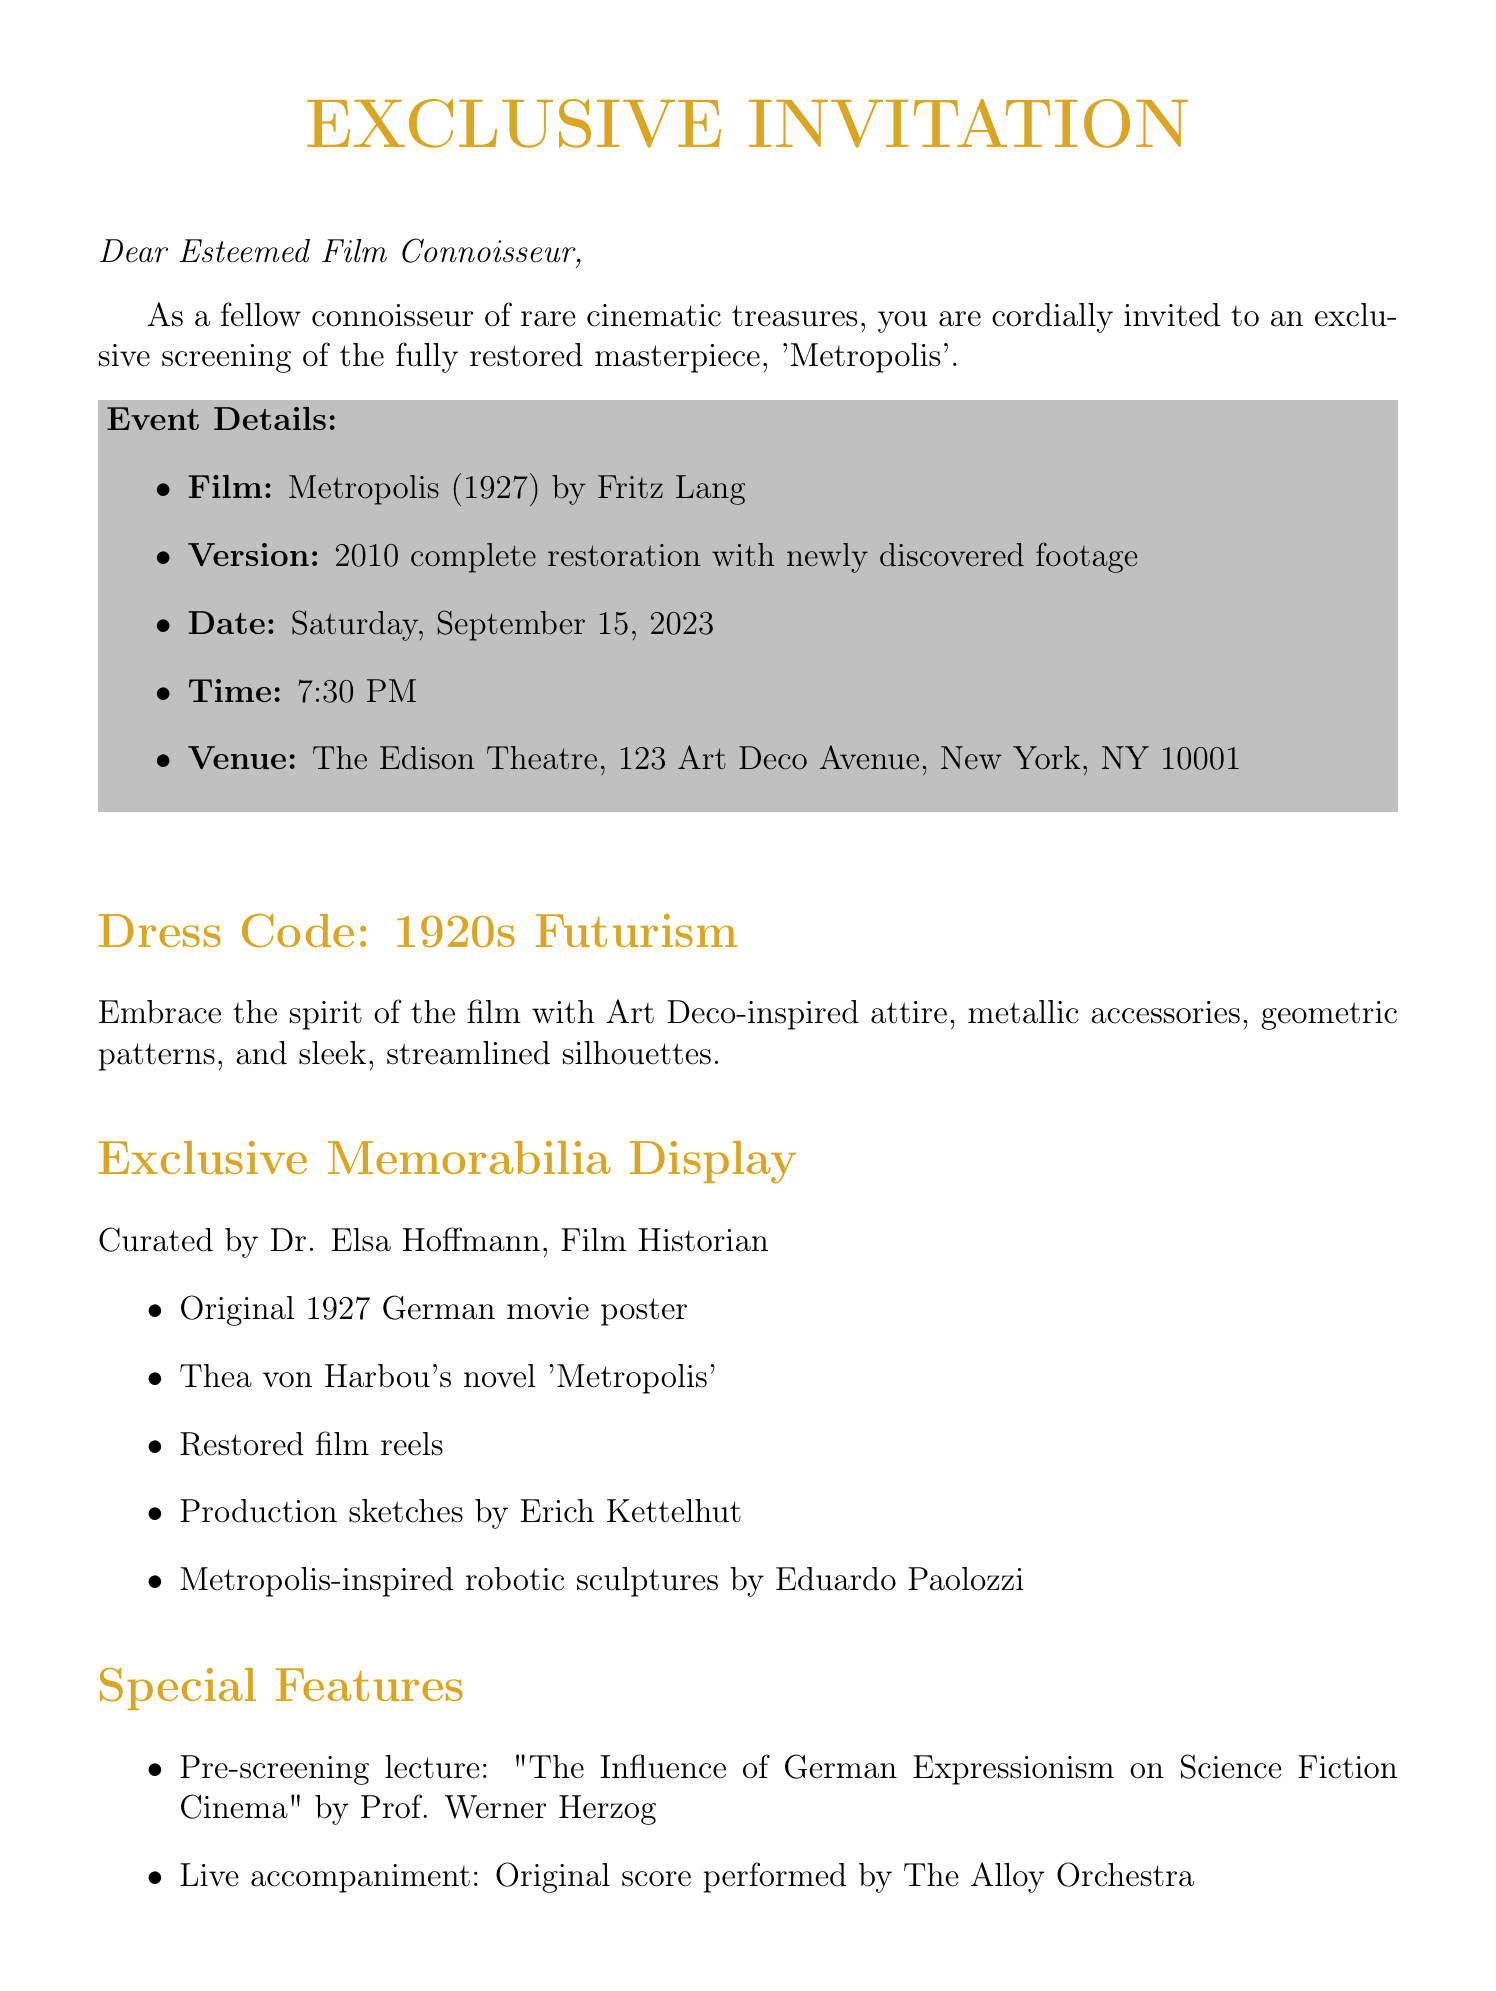What is the title of the movie being screened? The title of the movie is mentioned in the event details section of the document.
Answer: Metropolis Who directed the film? The document provides information about the director in the event details section.
Answer: Fritz Lang What year was the original movie released? The year of the original release is included in the event details.
Answer: 1927 What is the date of the screening? The screening date is clearly stated in the event details section of the document.
Answer: Saturday, September 15, 2023 What is the name of the speaker for the pre-screening lecture? The document lists the speaker for the pre-screening lecture under special features.
Answer: Prof. Werner Herzog What themed cocktails are inspired by? The document mentions the inspiration for refreshments in the additional information section.
Answer: Weimar era How many limited edition Blu-ray sets are available for purchase? The document specifies the availability of the exclusive offer related to the Blu-ray sets.
Answer: 100 Who is curating the memorabilia display? The curator of the memorabilia display is mentioned within the exclusive memorabilia display section.
Answer: Dr. Elsa Hoffmann What is the dress code theme? The dress code theme is outlined in the document under dress code.
Answer: 1920s Futurism 